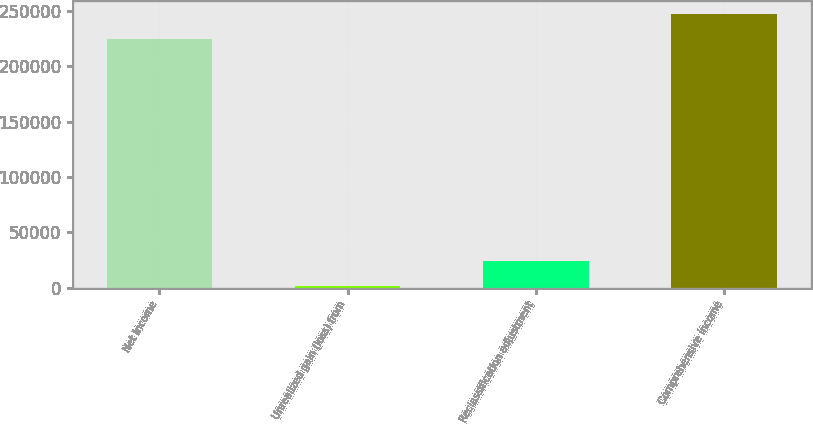<chart> <loc_0><loc_0><loc_500><loc_500><bar_chart><fcel>Net income<fcel>Unrealized gain (loss) from<fcel>Reclassification adjustment<fcel>Comprehensive income<nl><fcel>224402<fcel>1500<fcel>24076.6<fcel>246979<nl></chart> 